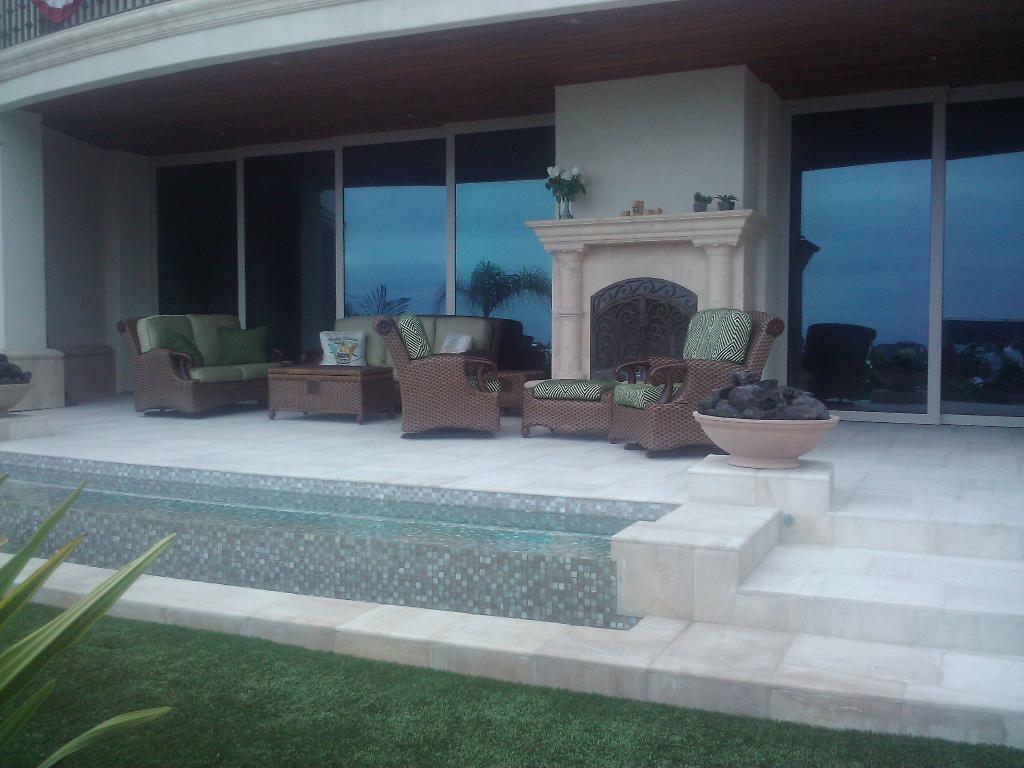Can you describe this image briefly? This is a building. We can see windows, flower vases here. We can see empty sofas and chairs with pillows. This is a fresh green grass. 